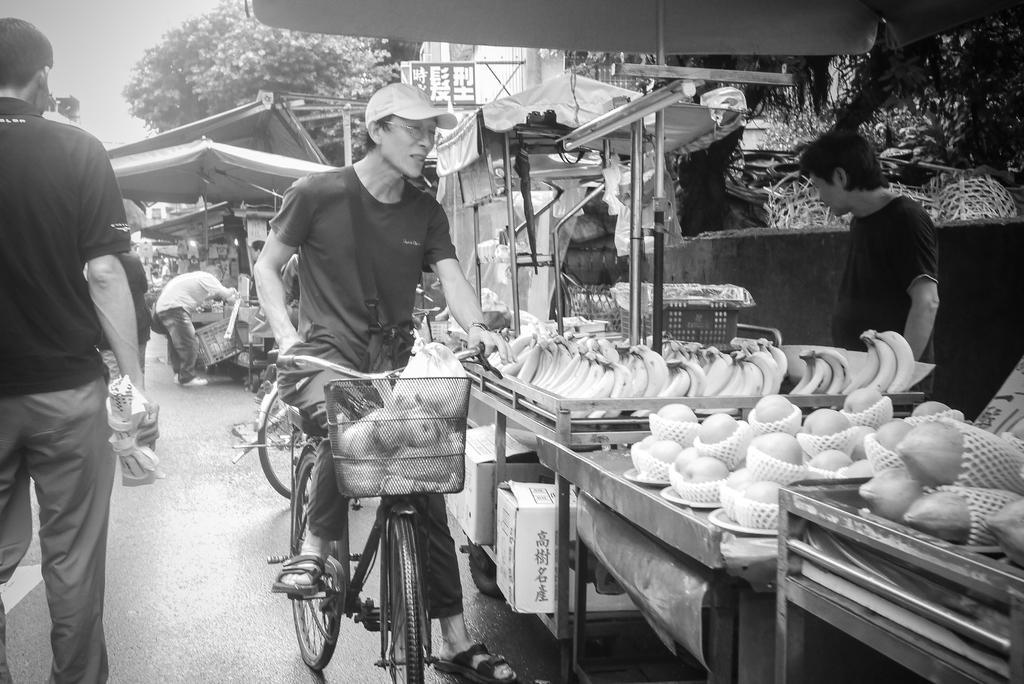Can you describe this image briefly? This man is sitting on a bicycle, in-front of this bicycle there is a basket. He wore cap. This man is standing, in-front of this person there is a table, on a table there are fruits. This is tent. Far there is a tree. This man is standing and holding a bag. Far the man is standing. 